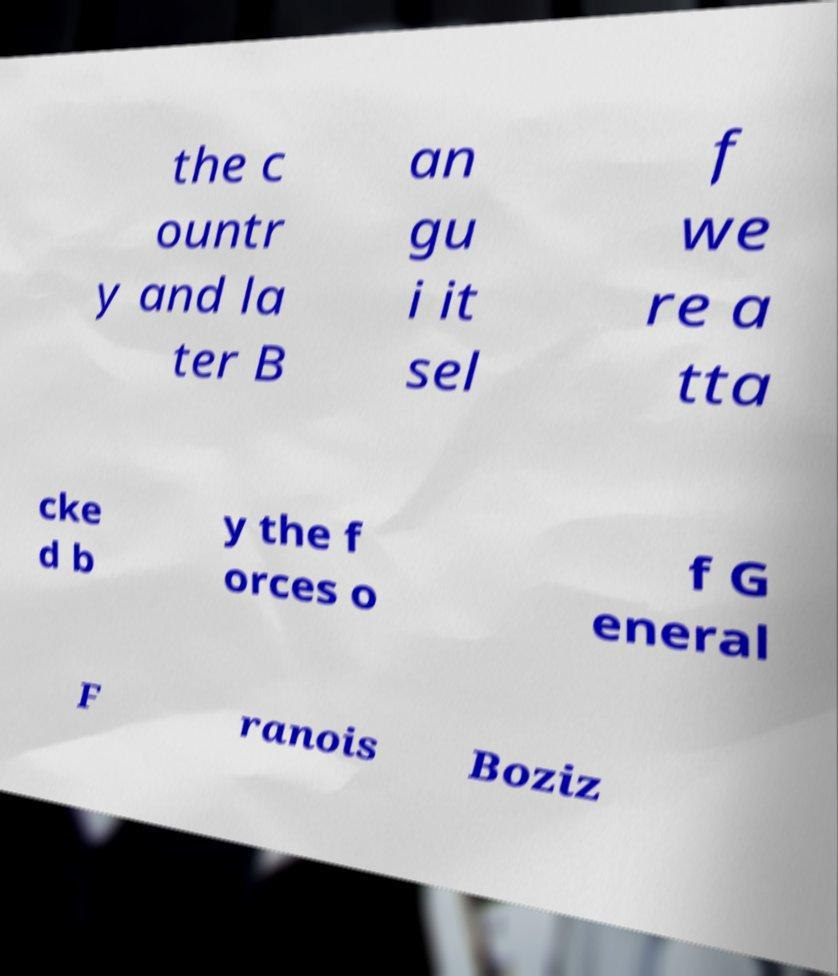Please read and relay the text visible in this image. What does it say? the c ountr y and la ter B an gu i it sel f we re a tta cke d b y the f orces o f G eneral F ranois Boziz 